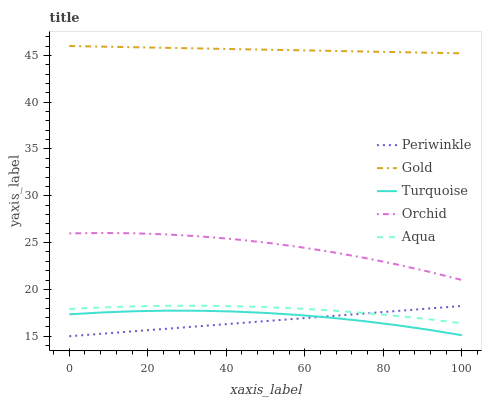Does Periwinkle have the minimum area under the curve?
Answer yes or no. Yes. Does Gold have the maximum area under the curve?
Answer yes or no. Yes. Does Turquoise have the minimum area under the curve?
Answer yes or no. No. Does Turquoise have the maximum area under the curve?
Answer yes or no. No. Is Periwinkle the smoothest?
Answer yes or no. Yes. Is Orchid the roughest?
Answer yes or no. Yes. Is Turquoise the smoothest?
Answer yes or no. No. Is Turquoise the roughest?
Answer yes or no. No. Does Periwinkle have the lowest value?
Answer yes or no. Yes. Does Turquoise have the lowest value?
Answer yes or no. No. Does Gold have the highest value?
Answer yes or no. Yes. Does Periwinkle have the highest value?
Answer yes or no. No. Is Turquoise less than Gold?
Answer yes or no. Yes. Is Aqua greater than Turquoise?
Answer yes or no. Yes. Does Periwinkle intersect Turquoise?
Answer yes or no. Yes. Is Periwinkle less than Turquoise?
Answer yes or no. No. Is Periwinkle greater than Turquoise?
Answer yes or no. No. Does Turquoise intersect Gold?
Answer yes or no. No. 